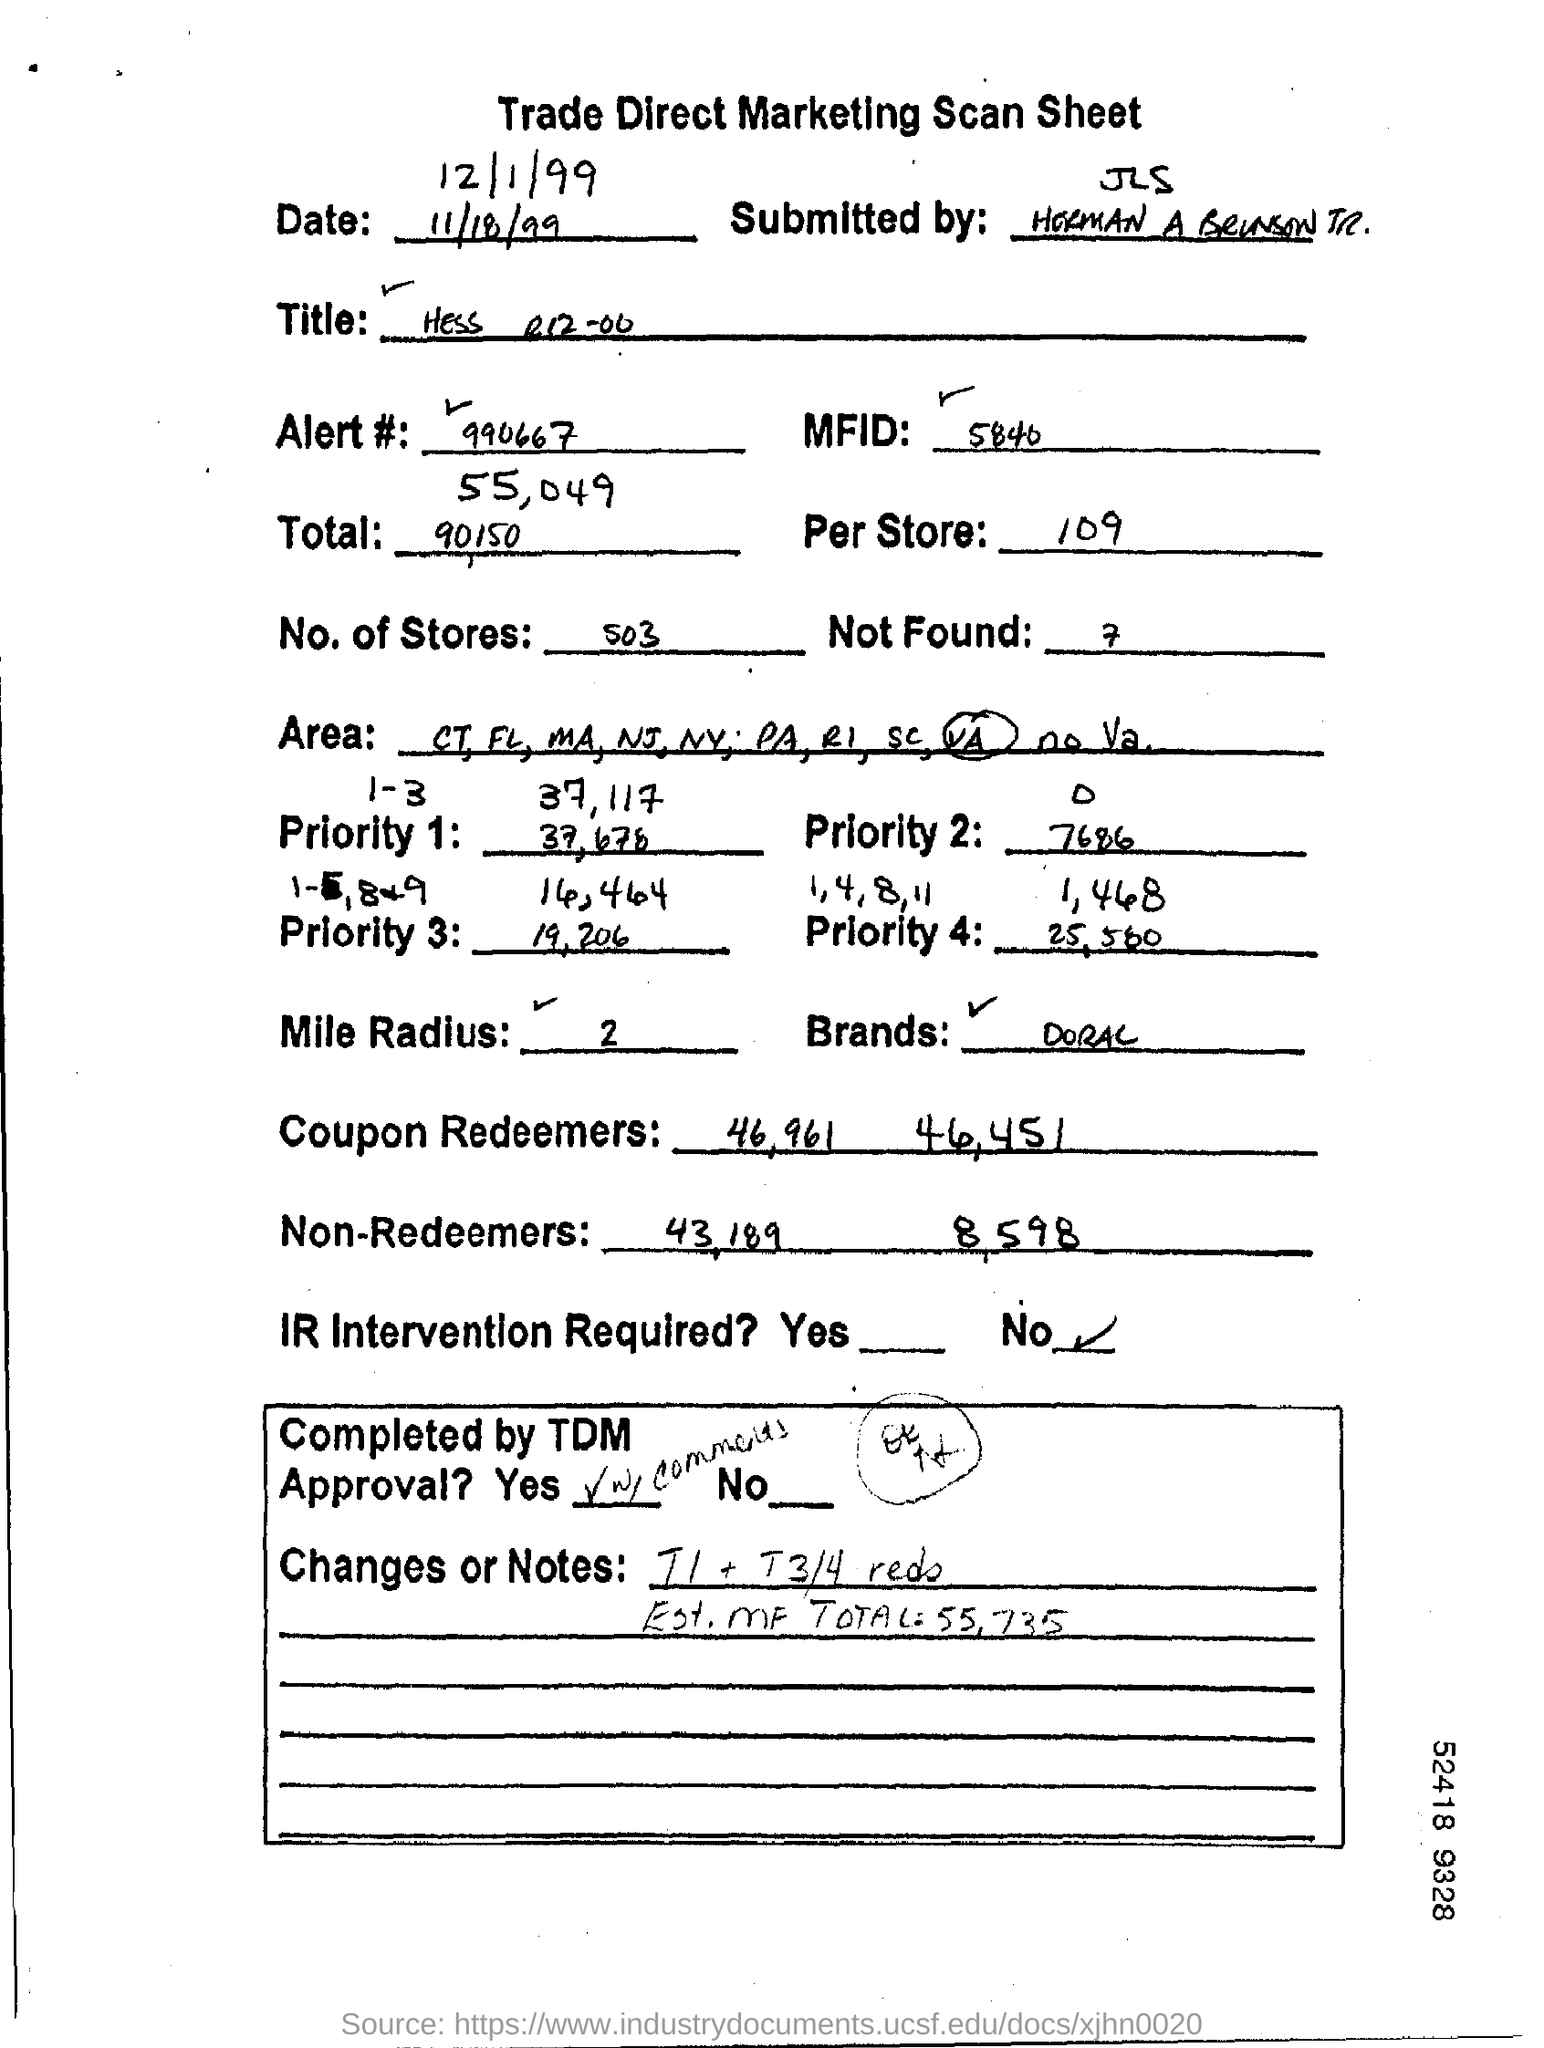Point out several critical features in this image. There are 503 stores. It is not clear what you are asking to convert. Please provide more context or clarify your question. The number provided is 990667... It is not necessary to intervene with the IR. The mile radius is a unit of measurement used to describe the distance around a circle or sphere. It is equal to 5,280 feet or 3,600 yards. The mile is often used in navigation and mapping to describe the distance between two points. 